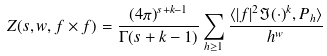Convert formula to latex. <formula><loc_0><loc_0><loc_500><loc_500>Z ( s , w , f \times f ) = \frac { ( 4 \pi ) ^ { s + k - 1 } } { \Gamma ( s + k - 1 ) } \sum _ { h \geq 1 } \frac { \langle | f | ^ { 2 } \Im ( \cdot ) ^ { k } , P _ { h } \rangle } { h ^ { w } }</formula> 